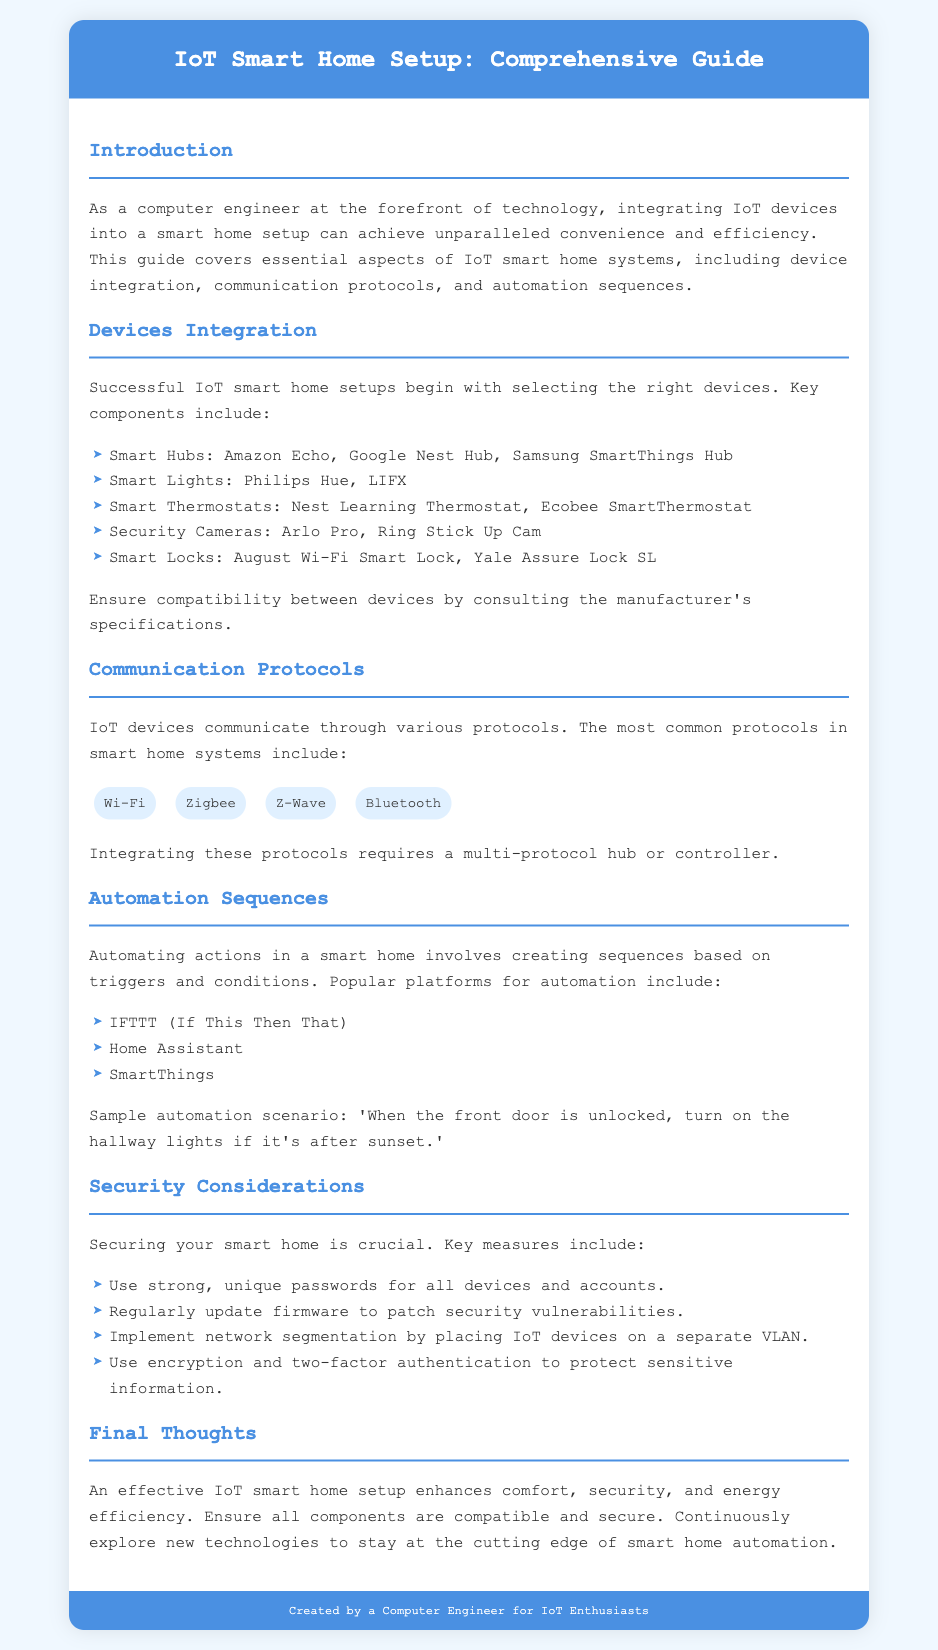what are the examples of smart hubs? The document lists specific smart hubs that can be used in an IoT smart home setup.
Answer: Amazon Echo, Google Nest Hub, Samsung SmartThings Hub which smart lights are mentioned? The document specifies which smart lights are suitable for integration into a smart home.
Answer: Philips Hue, LIFX what is one example of a communication protocol? The document provides several options for communication protocols used in smart home systems.
Answer: Wi-Fi what is a sample automation scenario provided in the document? The document describes a specific example of how automation can work in a smart home.
Answer: When the front door is unlocked, turn on the hallway lights if it's after sunset what security measure is suggested for IoT devices? The document highlights key security measures to protect smart home setups.
Answer: Use strong, unique passwords for all devices and accounts 